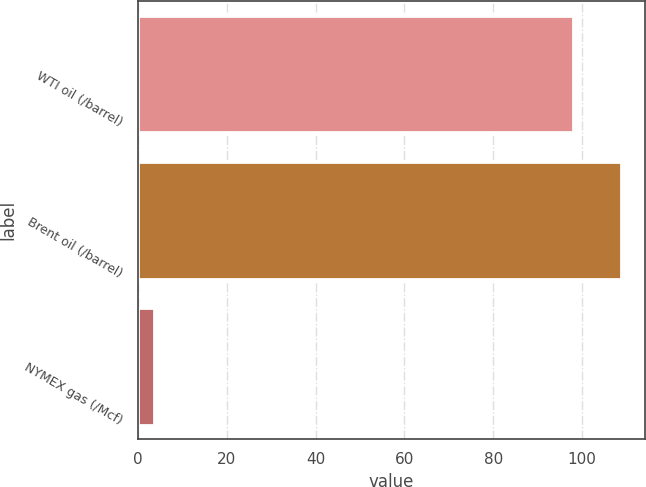Convert chart. <chart><loc_0><loc_0><loc_500><loc_500><bar_chart><fcel>WTI oil (/barrel)<fcel>Brent oil (/barrel)<fcel>NYMEX gas (/Mcf)<nl><fcel>97.97<fcel>108.76<fcel>3.66<nl></chart> 